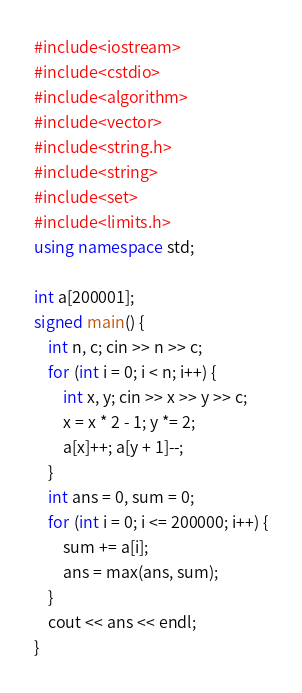<code> <loc_0><loc_0><loc_500><loc_500><_C++_>#include<iostream>
#include<cstdio>
#include<algorithm>
#include<vector>
#include<string.h>
#include<string>
#include<set>
#include<limits.h>
using namespace std;

int a[200001];
signed main() {
	int n, c; cin >> n >> c;
	for (int i = 0; i < n; i++) {
		int x, y; cin >> x >> y >> c;
		x = x * 2 - 1; y *= 2;
		a[x]++; a[y + 1]--;
	}
	int ans = 0, sum = 0;
	for (int i = 0; i <= 200000; i++) {
		sum += a[i];
		ans = max(ans, sum);
	}
	cout << ans << endl;
}</code> 